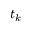Convert formula to latex. <formula><loc_0><loc_0><loc_500><loc_500>t _ { k }</formula> 